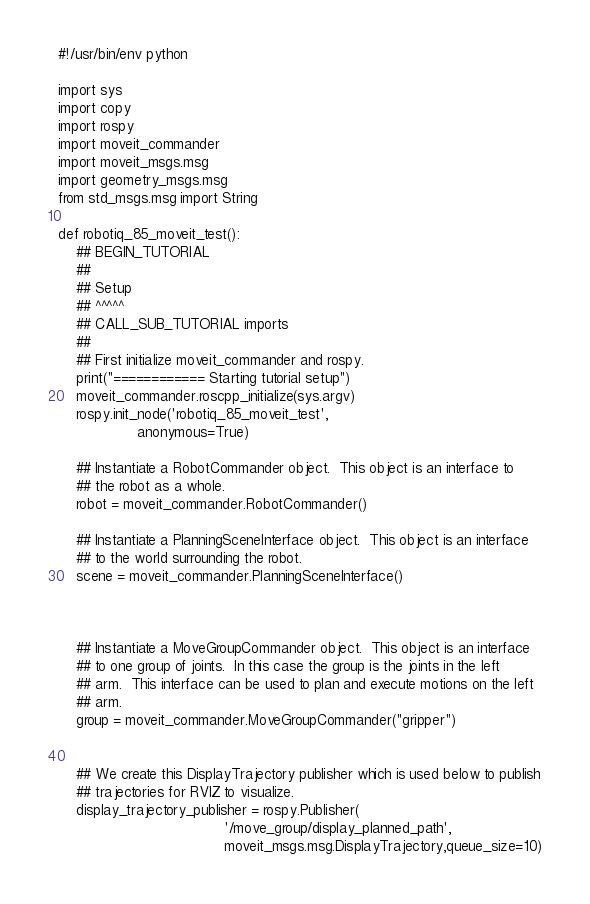<code> <loc_0><loc_0><loc_500><loc_500><_Python_>#!/usr/bin/env python

import sys
import copy
import rospy
import moveit_commander
import moveit_msgs.msg
import geometry_msgs.msg
from std_msgs.msg import String

def robotiq_85_moveit_test():
    ## BEGIN_TUTORIAL
    ##
    ## Setup
    ## ^^^^^
    ## CALL_SUB_TUTORIAL imports
    ##
    ## First initialize moveit_commander and rospy.
    print("============ Starting tutorial setup")
    moveit_commander.roscpp_initialize(sys.argv)
    rospy.init_node('robotiq_85_moveit_test',
                  anonymous=True)

    ## Instantiate a RobotCommander object.  This object is an interface to
    ## the robot as a whole.
    robot = moveit_commander.RobotCommander()

    ## Instantiate a PlanningSceneInterface object.  This object is an interface
    ## to the world surrounding the robot.
    scene = moveit_commander.PlanningSceneInterface()



    ## Instantiate a MoveGroupCommander object.  This object is an interface
    ## to one group of joints.  In this case the group is the joints in the left
    ## arm.  This interface can be used to plan and execute motions on the left
    ## arm.
    group = moveit_commander.MoveGroupCommander("gripper")


    ## We create this DisplayTrajectory publisher which is used below to publish
    ## trajectories for RVIZ to visualize.
    display_trajectory_publisher = rospy.Publisher(
                                      '/move_group/display_planned_path',
                                      moveit_msgs.msg.DisplayTrajectory,queue_size=10)
</code> 